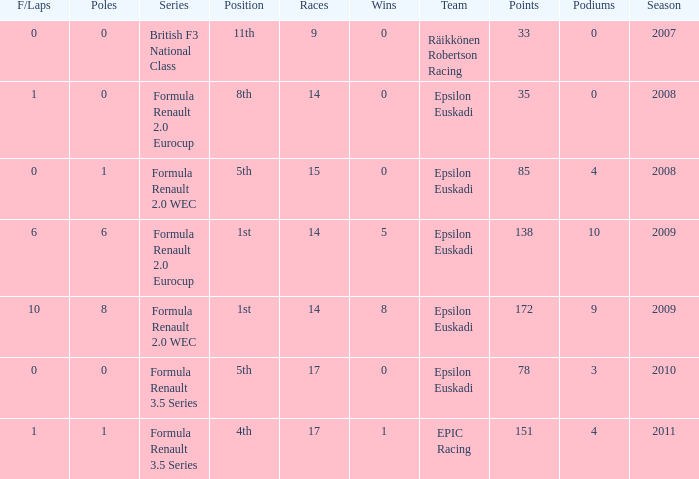Could you parse the entire table? {'header': ['F/Laps', 'Poles', 'Series', 'Position', 'Races', 'Wins', 'Team', 'Points', 'Podiums', 'Season'], 'rows': [['0', '0', 'British F3 National Class', '11th', '9', '0', 'Räikkönen Robertson Racing', '33', '0', '2007'], ['1', '0', 'Formula Renault 2.0 Eurocup', '8th', '14', '0', 'Epsilon Euskadi', '35', '0', '2008'], ['0', '1', 'Formula Renault 2.0 WEC', '5th', '15', '0', 'Epsilon Euskadi', '85', '4', '2008'], ['6', '6', 'Formula Renault 2.0 Eurocup', '1st', '14', '5', 'Epsilon Euskadi', '138', '10', '2009'], ['10', '8', 'Formula Renault 2.0 WEC', '1st', '14', '8', 'Epsilon Euskadi', '172', '9', '2009'], ['0', '0', 'Formula Renault 3.5 Series', '5th', '17', '0', 'Epsilon Euskadi', '78', '3', '2010'], ['1', '1', 'Formula Renault 3.5 Series', '4th', '17', '1', 'EPIC Racing', '151', '4', '2011']]} How many podiums when he was in the british f3 national class series? 1.0. 